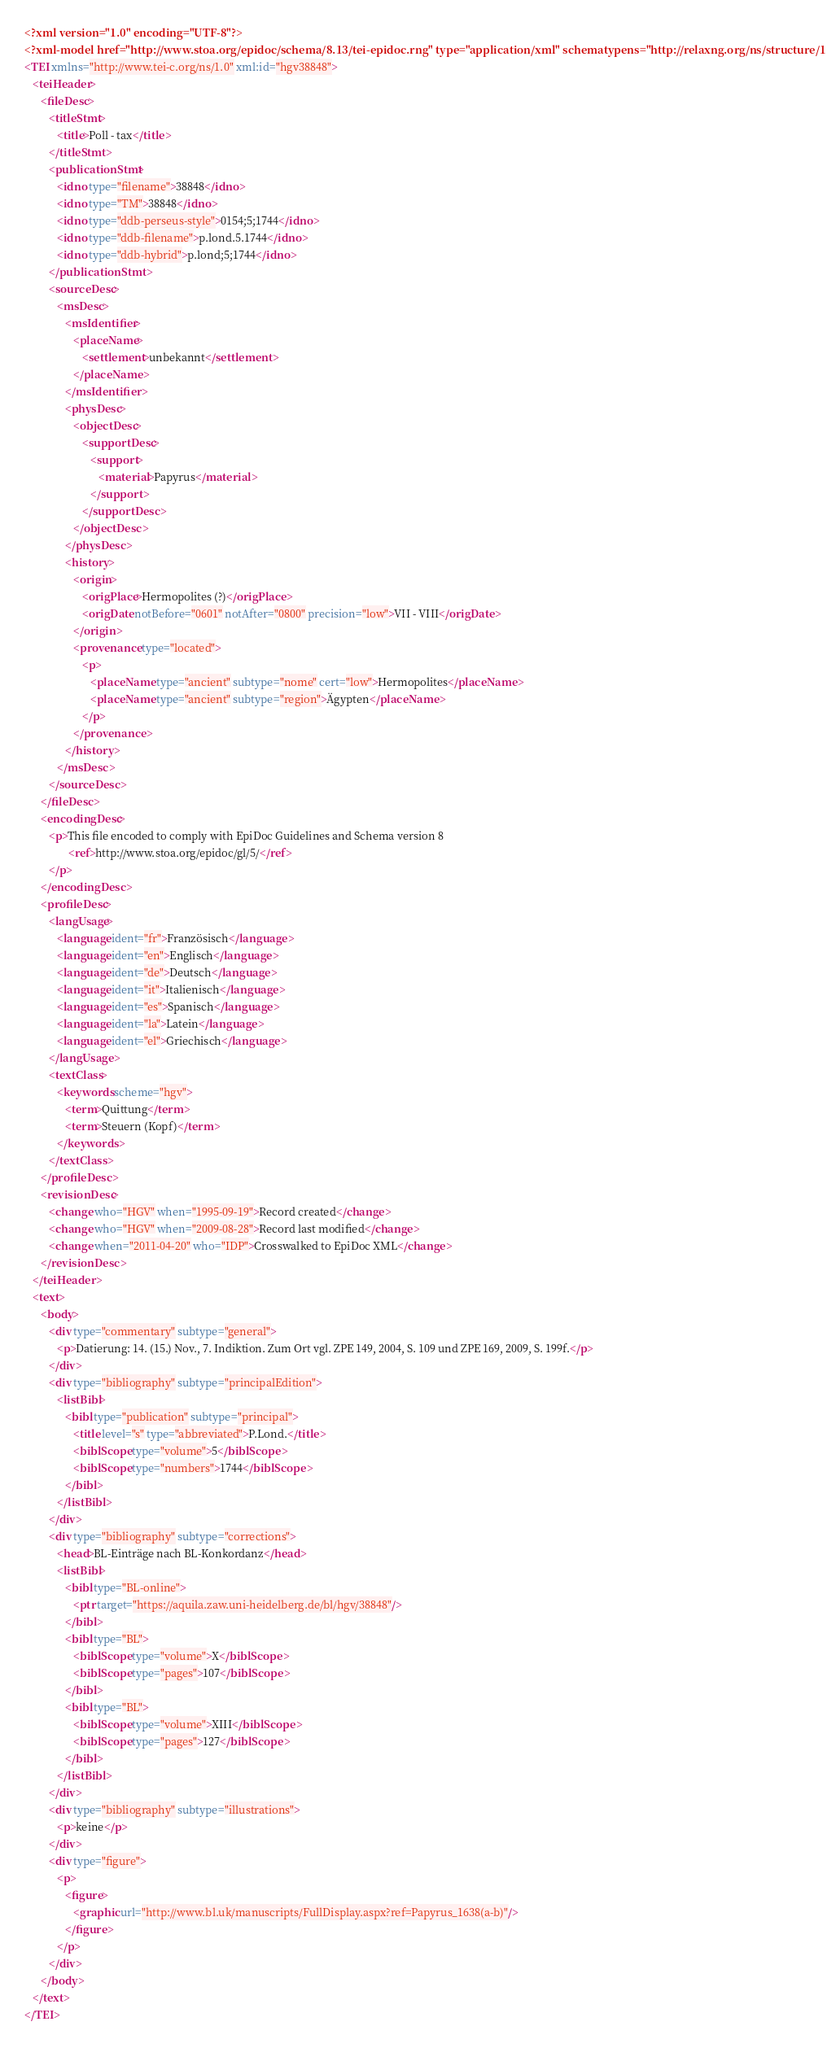Convert code to text. <code><loc_0><loc_0><loc_500><loc_500><_XML_><?xml version="1.0" encoding="UTF-8"?>
<?xml-model href="http://www.stoa.org/epidoc/schema/8.13/tei-epidoc.rng" type="application/xml" schematypens="http://relaxng.org/ns/structure/1.0"?>
<TEI xmlns="http://www.tei-c.org/ns/1.0" xml:id="hgv38848">
   <teiHeader>
      <fileDesc>
         <titleStmt>
            <title>Poll - tax</title>
         </titleStmt>
         <publicationStmt>
            <idno type="filename">38848</idno>
            <idno type="TM">38848</idno>
            <idno type="ddb-perseus-style">0154;5;1744</idno>
            <idno type="ddb-filename">p.lond.5.1744</idno>
            <idno type="ddb-hybrid">p.lond;5;1744</idno>
         </publicationStmt>
         <sourceDesc>
            <msDesc>
               <msIdentifier>
                  <placeName>
                     <settlement>unbekannt</settlement>
                  </placeName>
               </msIdentifier>
               <physDesc>
                  <objectDesc>
                     <supportDesc>
                        <support>
                           <material>Papyrus</material>
                        </support>
                     </supportDesc>
                  </objectDesc>
               </physDesc>
               <history>
                  <origin>
                     <origPlace>Hermopolites (?)</origPlace>
                     <origDate notBefore="0601" notAfter="0800" precision="low">VII - VIII</origDate>
                  </origin>
                  <provenance type="located">
                     <p>
                        <placeName type="ancient" subtype="nome" cert="low">Hermopolites</placeName>
                        <placeName type="ancient" subtype="region">Ägypten</placeName>
                     </p>
                  </provenance>
               </history>
            </msDesc>
         </sourceDesc>
      </fileDesc>
      <encodingDesc>
         <p>This file encoded to comply with EpiDoc Guidelines and Schema version 8
                <ref>http://www.stoa.org/epidoc/gl/5/</ref>
         </p>
      </encodingDesc>
      <profileDesc>
         <langUsage>
            <language ident="fr">Französisch</language>
            <language ident="en">Englisch</language>
            <language ident="de">Deutsch</language>
            <language ident="it">Italienisch</language>
            <language ident="es">Spanisch</language>
            <language ident="la">Latein</language>
            <language ident="el">Griechisch</language>
         </langUsage>
         <textClass>
            <keywords scheme="hgv">
               <term>Quittung</term>
               <term>Steuern (Kopf)</term>
            </keywords>
         </textClass>
      </profileDesc>
      <revisionDesc>
         <change who="HGV" when="1995-09-19">Record created</change>
         <change who="HGV" when="2009-08-28">Record last modified</change>
         <change when="2011-04-20" who="IDP">Crosswalked to EpiDoc XML</change>
      </revisionDesc>
   </teiHeader>
   <text>
      <body>
         <div type="commentary" subtype="general">
            <p>Datierung: 14. (15.) Nov., 7. Indiktion. Zum Ort vgl. ZPE 149, 2004, S. 109 und ZPE 169, 2009, S. 199f.</p>
         </div>
         <div type="bibliography" subtype="principalEdition">
            <listBibl>
               <bibl type="publication" subtype="principal">
                  <title level="s" type="abbreviated">P.Lond.</title>
                  <biblScope type="volume">5</biblScope>
                  <biblScope type="numbers">1744</biblScope>
               </bibl>
            </listBibl>
         </div>
         <div type="bibliography" subtype="corrections">
            <head>BL-Einträge nach BL-Konkordanz</head>
            <listBibl>
               <bibl type="BL-online">
                  <ptr target="https://aquila.zaw.uni-heidelberg.de/bl/hgv/38848"/>
               </bibl>
               <bibl type="BL">
                  <biblScope type="volume">X</biblScope>
                  <biblScope type="pages">107</biblScope>
               </bibl>
               <bibl type="BL">
                  <biblScope type="volume">XIII</biblScope>
                  <biblScope type="pages">127</biblScope>
               </bibl>
            </listBibl>
         </div>
         <div type="bibliography" subtype="illustrations">
            <p>keine</p>
         </div>
         <div type="figure">
            <p>
               <figure>
                  <graphic url="http://www.bl.uk/manuscripts/FullDisplay.aspx?ref=Papyrus_1638(a-b)"/>
               </figure>
            </p>
         </div>
      </body>
   </text>
</TEI>
</code> 